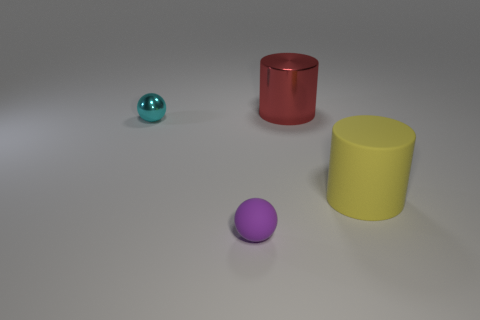Is there a tiny cyan object that has the same shape as the small purple matte thing? Yes, there is indeed a tiny cyan object, which appears to be a sphere, sharing its shape with the small purple object, also a sphere, located towards the front. 